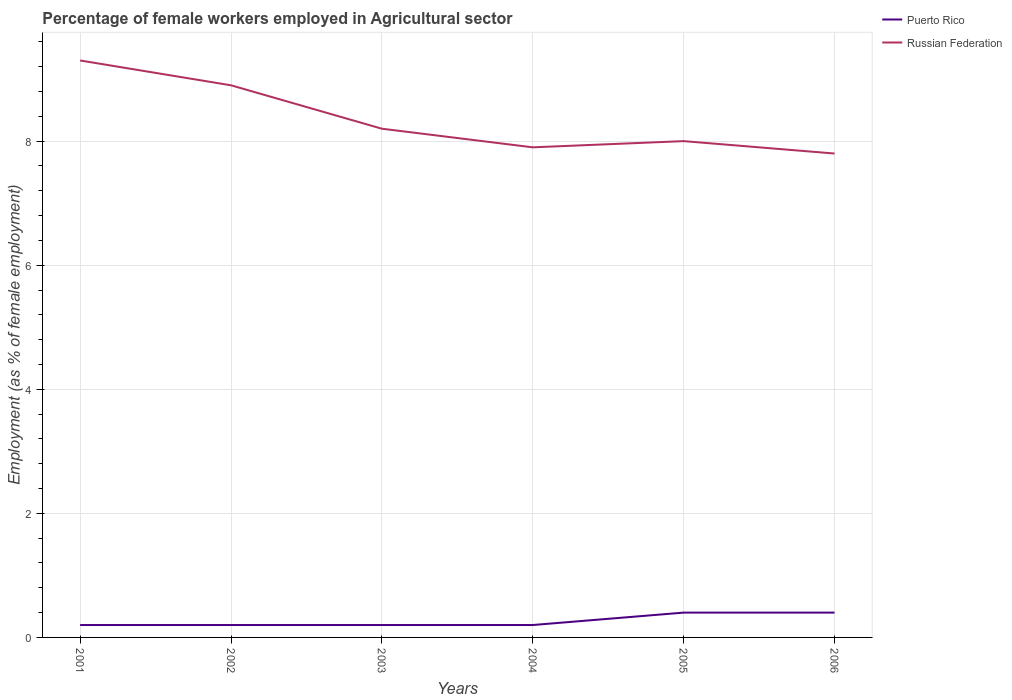How many different coloured lines are there?
Provide a succinct answer. 2. Is the number of lines equal to the number of legend labels?
Your answer should be very brief. Yes. Across all years, what is the maximum percentage of females employed in Agricultural sector in Puerto Rico?
Give a very brief answer. 0.2. In which year was the percentage of females employed in Agricultural sector in Russian Federation maximum?
Keep it short and to the point. 2006. What is the difference between the highest and the second highest percentage of females employed in Agricultural sector in Russian Federation?
Make the answer very short. 1.5. Is the percentage of females employed in Agricultural sector in Russian Federation strictly greater than the percentage of females employed in Agricultural sector in Puerto Rico over the years?
Offer a terse response. No. How many lines are there?
Ensure brevity in your answer.  2. How many years are there in the graph?
Your answer should be compact. 6. Are the values on the major ticks of Y-axis written in scientific E-notation?
Provide a succinct answer. No. Does the graph contain grids?
Provide a short and direct response. Yes. How are the legend labels stacked?
Your answer should be compact. Vertical. What is the title of the graph?
Give a very brief answer. Percentage of female workers employed in Agricultural sector. Does "Korea (Republic)" appear as one of the legend labels in the graph?
Provide a short and direct response. No. What is the label or title of the Y-axis?
Offer a very short reply. Employment (as % of female employment). What is the Employment (as % of female employment) in Puerto Rico in 2001?
Your answer should be compact. 0.2. What is the Employment (as % of female employment) in Russian Federation in 2001?
Keep it short and to the point. 9.3. What is the Employment (as % of female employment) of Puerto Rico in 2002?
Offer a terse response. 0.2. What is the Employment (as % of female employment) in Russian Federation in 2002?
Offer a very short reply. 8.9. What is the Employment (as % of female employment) in Puerto Rico in 2003?
Provide a short and direct response. 0.2. What is the Employment (as % of female employment) in Russian Federation in 2003?
Make the answer very short. 8.2. What is the Employment (as % of female employment) of Puerto Rico in 2004?
Your response must be concise. 0.2. What is the Employment (as % of female employment) in Russian Federation in 2004?
Your answer should be compact. 7.9. What is the Employment (as % of female employment) of Puerto Rico in 2005?
Ensure brevity in your answer.  0.4. What is the Employment (as % of female employment) in Puerto Rico in 2006?
Provide a short and direct response. 0.4. What is the Employment (as % of female employment) of Russian Federation in 2006?
Make the answer very short. 7.8. Across all years, what is the maximum Employment (as % of female employment) in Puerto Rico?
Ensure brevity in your answer.  0.4. Across all years, what is the maximum Employment (as % of female employment) in Russian Federation?
Provide a short and direct response. 9.3. Across all years, what is the minimum Employment (as % of female employment) in Puerto Rico?
Your response must be concise. 0.2. Across all years, what is the minimum Employment (as % of female employment) in Russian Federation?
Your answer should be compact. 7.8. What is the total Employment (as % of female employment) of Russian Federation in the graph?
Give a very brief answer. 50.1. What is the difference between the Employment (as % of female employment) of Puerto Rico in 2001 and that in 2003?
Offer a very short reply. 0. What is the difference between the Employment (as % of female employment) of Puerto Rico in 2001 and that in 2004?
Keep it short and to the point. 0. What is the difference between the Employment (as % of female employment) in Russian Federation in 2001 and that in 2004?
Keep it short and to the point. 1.4. What is the difference between the Employment (as % of female employment) in Puerto Rico in 2001 and that in 2006?
Your answer should be compact. -0.2. What is the difference between the Employment (as % of female employment) of Russian Federation in 2001 and that in 2006?
Offer a very short reply. 1.5. What is the difference between the Employment (as % of female employment) in Puerto Rico in 2002 and that in 2003?
Offer a very short reply. 0. What is the difference between the Employment (as % of female employment) in Russian Federation in 2002 and that in 2003?
Provide a succinct answer. 0.7. What is the difference between the Employment (as % of female employment) of Russian Federation in 2002 and that in 2004?
Provide a short and direct response. 1. What is the difference between the Employment (as % of female employment) of Puerto Rico in 2002 and that in 2005?
Your answer should be very brief. -0.2. What is the difference between the Employment (as % of female employment) of Russian Federation in 2002 and that in 2005?
Provide a succinct answer. 0.9. What is the difference between the Employment (as % of female employment) of Puerto Rico in 2002 and that in 2006?
Give a very brief answer. -0.2. What is the difference between the Employment (as % of female employment) in Puerto Rico in 2003 and that in 2004?
Give a very brief answer. 0. What is the difference between the Employment (as % of female employment) of Russian Federation in 2003 and that in 2004?
Keep it short and to the point. 0.3. What is the difference between the Employment (as % of female employment) in Russian Federation in 2003 and that in 2005?
Provide a succinct answer. 0.2. What is the difference between the Employment (as % of female employment) in Russian Federation in 2004 and that in 2005?
Give a very brief answer. -0.1. What is the difference between the Employment (as % of female employment) of Puerto Rico in 2001 and the Employment (as % of female employment) of Russian Federation in 2004?
Keep it short and to the point. -7.7. What is the difference between the Employment (as % of female employment) of Puerto Rico in 2002 and the Employment (as % of female employment) of Russian Federation in 2003?
Provide a succinct answer. -8. What is the difference between the Employment (as % of female employment) of Puerto Rico in 2002 and the Employment (as % of female employment) of Russian Federation in 2004?
Offer a very short reply. -7.7. What is the difference between the Employment (as % of female employment) of Puerto Rico in 2003 and the Employment (as % of female employment) of Russian Federation in 2004?
Keep it short and to the point. -7.7. What is the difference between the Employment (as % of female employment) of Puerto Rico in 2003 and the Employment (as % of female employment) of Russian Federation in 2005?
Offer a very short reply. -7.8. What is the difference between the Employment (as % of female employment) in Puerto Rico in 2004 and the Employment (as % of female employment) in Russian Federation in 2005?
Make the answer very short. -7.8. What is the difference between the Employment (as % of female employment) of Puerto Rico in 2004 and the Employment (as % of female employment) of Russian Federation in 2006?
Keep it short and to the point. -7.6. What is the average Employment (as % of female employment) of Puerto Rico per year?
Ensure brevity in your answer.  0.27. What is the average Employment (as % of female employment) of Russian Federation per year?
Your answer should be compact. 8.35. In the year 2001, what is the difference between the Employment (as % of female employment) in Puerto Rico and Employment (as % of female employment) in Russian Federation?
Make the answer very short. -9.1. In the year 2002, what is the difference between the Employment (as % of female employment) of Puerto Rico and Employment (as % of female employment) of Russian Federation?
Offer a very short reply. -8.7. What is the ratio of the Employment (as % of female employment) of Puerto Rico in 2001 to that in 2002?
Provide a short and direct response. 1. What is the ratio of the Employment (as % of female employment) of Russian Federation in 2001 to that in 2002?
Your response must be concise. 1.04. What is the ratio of the Employment (as % of female employment) of Russian Federation in 2001 to that in 2003?
Make the answer very short. 1.13. What is the ratio of the Employment (as % of female employment) of Russian Federation in 2001 to that in 2004?
Offer a very short reply. 1.18. What is the ratio of the Employment (as % of female employment) of Russian Federation in 2001 to that in 2005?
Offer a terse response. 1.16. What is the ratio of the Employment (as % of female employment) of Russian Federation in 2001 to that in 2006?
Give a very brief answer. 1.19. What is the ratio of the Employment (as % of female employment) of Puerto Rico in 2002 to that in 2003?
Offer a terse response. 1. What is the ratio of the Employment (as % of female employment) in Russian Federation in 2002 to that in 2003?
Provide a succinct answer. 1.09. What is the ratio of the Employment (as % of female employment) in Russian Federation in 2002 to that in 2004?
Provide a succinct answer. 1.13. What is the ratio of the Employment (as % of female employment) of Puerto Rico in 2002 to that in 2005?
Provide a succinct answer. 0.5. What is the ratio of the Employment (as % of female employment) of Russian Federation in 2002 to that in 2005?
Keep it short and to the point. 1.11. What is the ratio of the Employment (as % of female employment) of Russian Federation in 2002 to that in 2006?
Offer a terse response. 1.14. What is the ratio of the Employment (as % of female employment) in Puerto Rico in 2003 to that in 2004?
Give a very brief answer. 1. What is the ratio of the Employment (as % of female employment) in Russian Federation in 2003 to that in 2004?
Make the answer very short. 1.04. What is the ratio of the Employment (as % of female employment) in Russian Federation in 2003 to that in 2005?
Your answer should be compact. 1.02. What is the ratio of the Employment (as % of female employment) in Russian Federation in 2003 to that in 2006?
Offer a terse response. 1.05. What is the ratio of the Employment (as % of female employment) in Russian Federation in 2004 to that in 2005?
Your response must be concise. 0.99. What is the ratio of the Employment (as % of female employment) in Puerto Rico in 2004 to that in 2006?
Your answer should be compact. 0.5. What is the ratio of the Employment (as % of female employment) in Russian Federation in 2004 to that in 2006?
Make the answer very short. 1.01. What is the ratio of the Employment (as % of female employment) in Russian Federation in 2005 to that in 2006?
Provide a succinct answer. 1.03. What is the difference between the highest and the second highest Employment (as % of female employment) of Russian Federation?
Make the answer very short. 0.4. What is the difference between the highest and the lowest Employment (as % of female employment) of Russian Federation?
Provide a short and direct response. 1.5. 